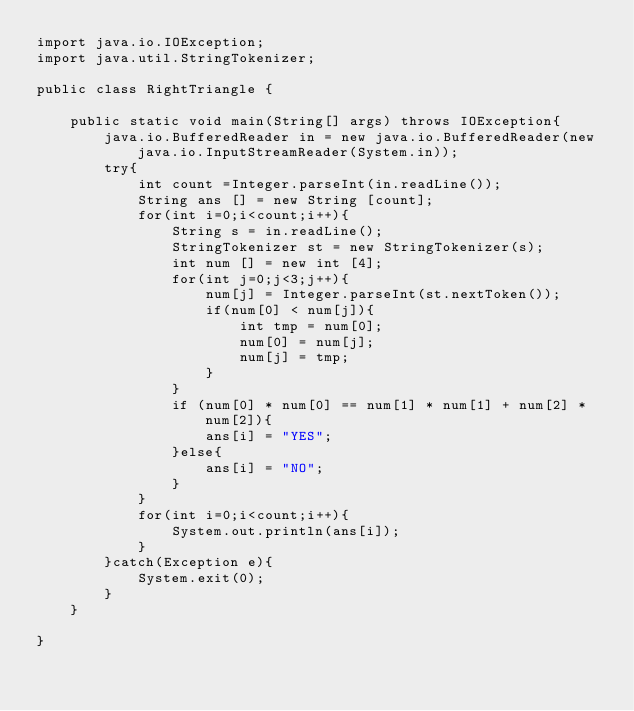<code> <loc_0><loc_0><loc_500><loc_500><_Java_>import java.io.IOException;
import java.util.StringTokenizer;

public class RightTriangle {

	public static void main(String[] args) throws IOException{
		java.io.BufferedReader in = new java.io.BufferedReader(new java.io.InputStreamReader(System.in));
		try{
			int count =Integer.parseInt(in.readLine());
			String ans [] = new String [count];
			for(int i=0;i<count;i++){
				String s = in.readLine();
				StringTokenizer st = new StringTokenizer(s);
				int num [] = new int [4];
				for(int j=0;j<3;j++){
					num[j] = Integer.parseInt(st.nextToken());
					if(num[0] < num[j]){
						int tmp = num[0];
						num[0] = num[j];
						num[j] = tmp;
					}
				}
				if (num[0] * num[0] == num[1] * num[1] + num[2] * num[2]){
					ans[i] = "YES";
				}else{
					ans[i] = "NO";
				}
			}
			for(int i=0;i<count;i++){
				System.out.println(ans[i]);
			}
		}catch(Exception e){
			System.exit(0);
		}
	}

}</code> 